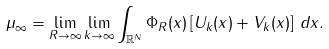Convert formula to latex. <formula><loc_0><loc_0><loc_500><loc_500>\mu _ { \infty } = \lim _ { R \to \infty } \lim _ { k \to \infty } \int _ { \mathbb { R } ^ { N } } \Phi _ { R } ( x ) \left [ U _ { k } ( x ) + V _ { k } ( x ) \right ] \, d x .</formula> 